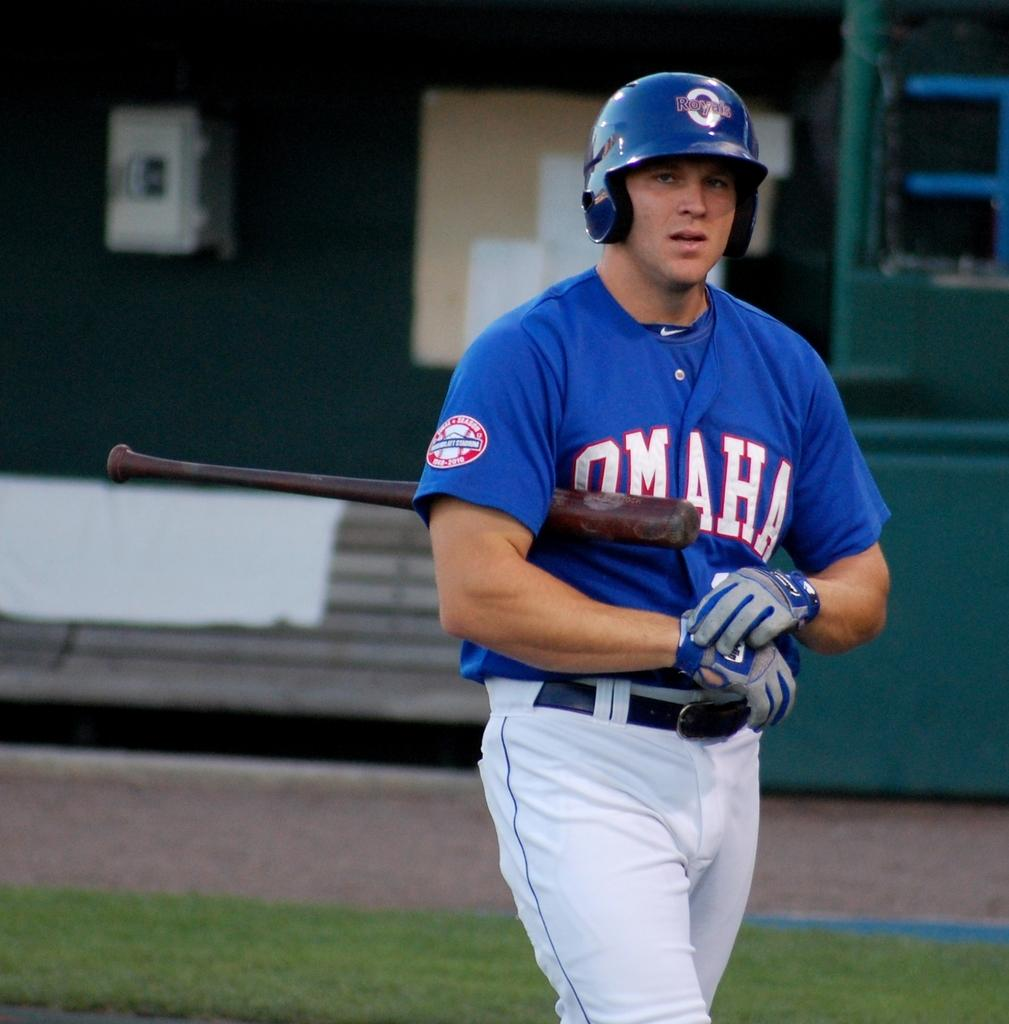<image>
Create a compact narrative representing the image presented. Baseball player for the Omaha team is walking with a bat on the field. 